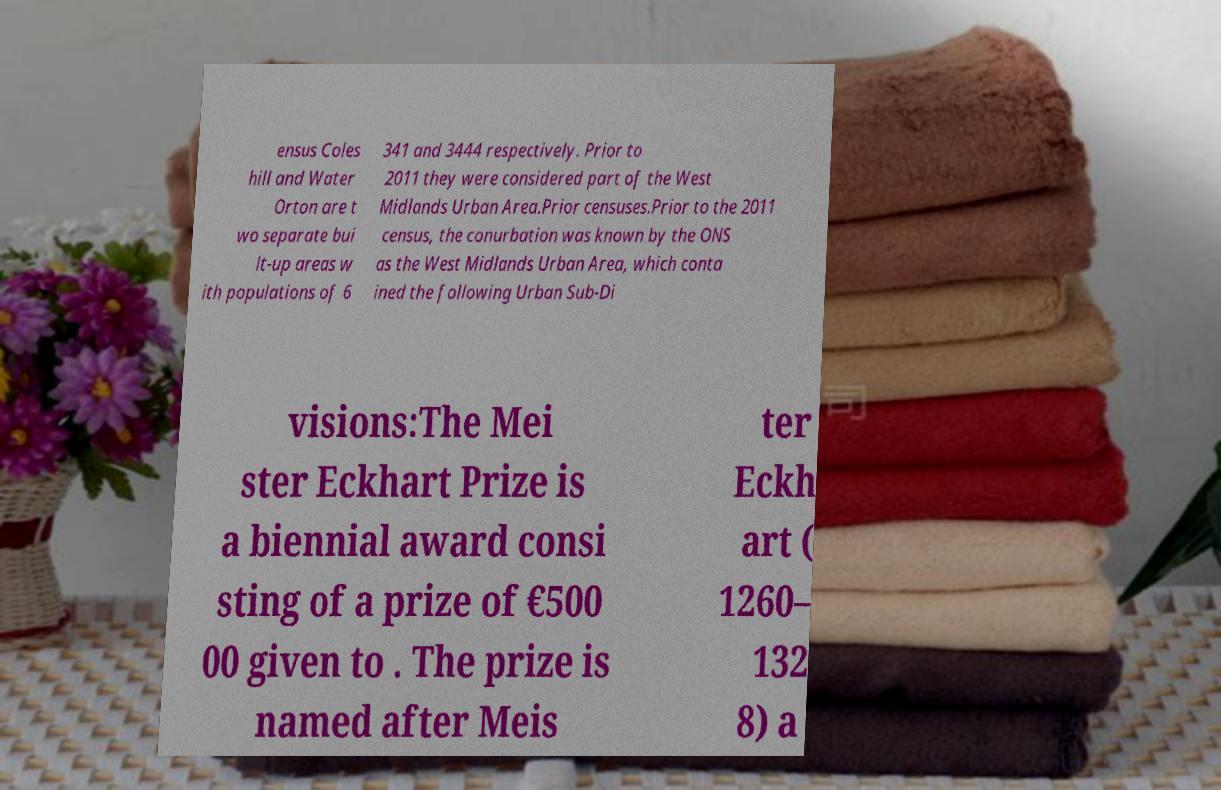Could you assist in decoding the text presented in this image and type it out clearly? ensus Coles hill and Water Orton are t wo separate bui lt-up areas w ith populations of 6 341 and 3444 respectively. Prior to 2011 they were considered part of the West Midlands Urban Area.Prior censuses.Prior to the 2011 census, the conurbation was known by the ONS as the West Midlands Urban Area, which conta ined the following Urban Sub-Di visions:The Mei ster Eckhart Prize is a biennial award consi sting of a prize of €500 00 given to . The prize is named after Meis ter Eckh art ( 1260– 132 8) a 